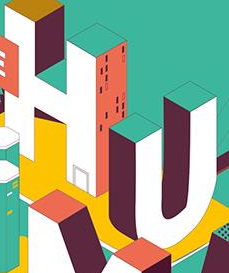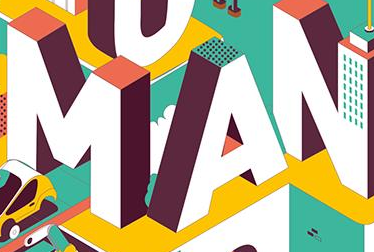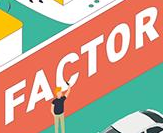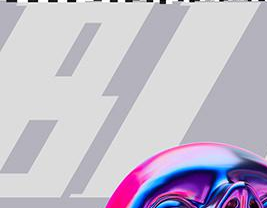What text is displayed in these images sequentially, separated by a semicolon? HU; MAN; FACTOR; BI 